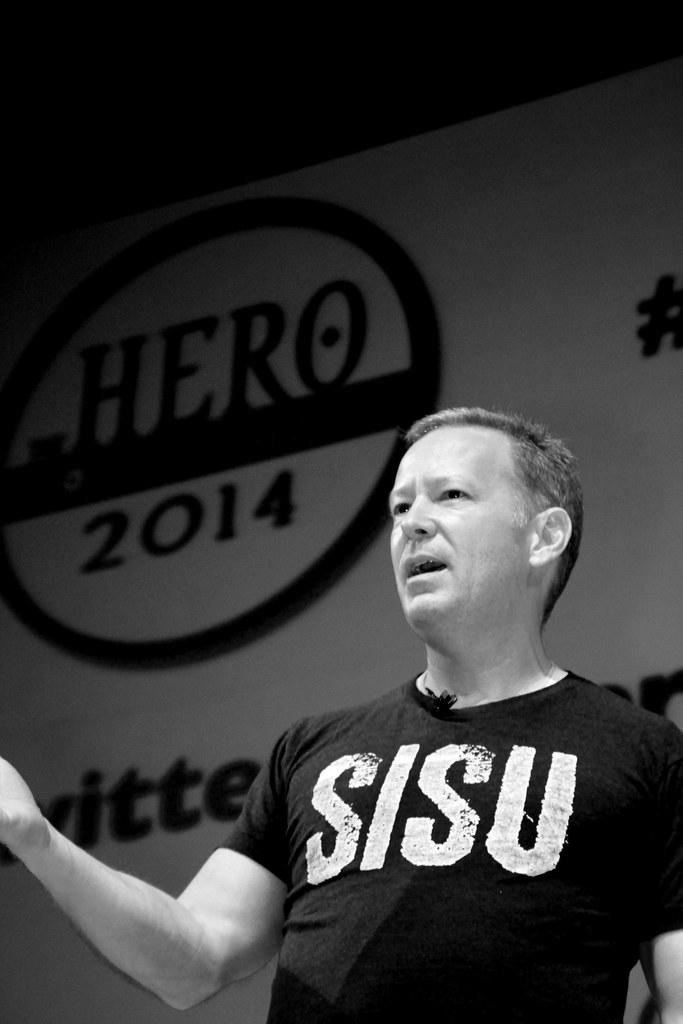Provide a one-sentence caption for the provided image. A black and white photo of a man giving a speech in front of a sign that says HERO 2014. 